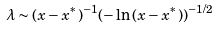<formula> <loc_0><loc_0><loc_500><loc_500>\lambda \sim ( x - x ^ { * } ) ^ { - 1 } ( - \ln { ( x - x ^ { * } ) } ) ^ { - 1 / 2 }</formula> 